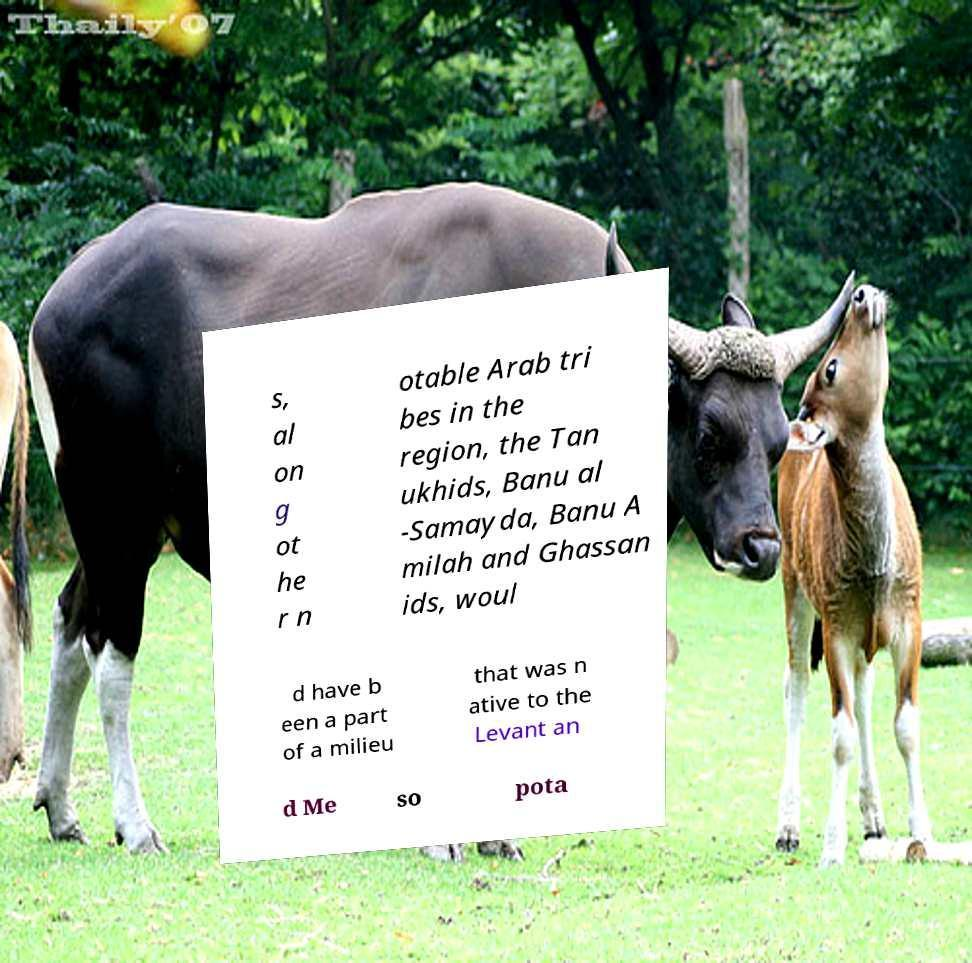What messages or text are displayed in this image? I need them in a readable, typed format. s, al on g ot he r n otable Arab tri bes in the region, the Tan ukhids, Banu al -Samayda, Banu A milah and Ghassan ids, woul d have b een a part of a milieu that was n ative to the Levant an d Me so pota 